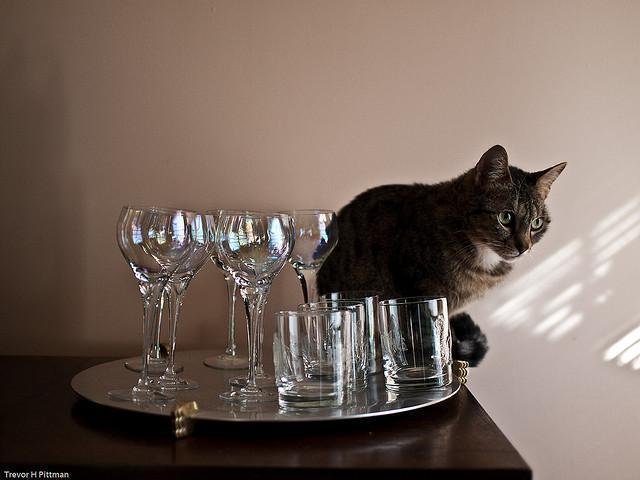How many wine glasses can be seen?
Give a very brief answer. 4. How many cups are in the picture?
Give a very brief answer. 2. How many cats can be seen?
Give a very brief answer. 1. 